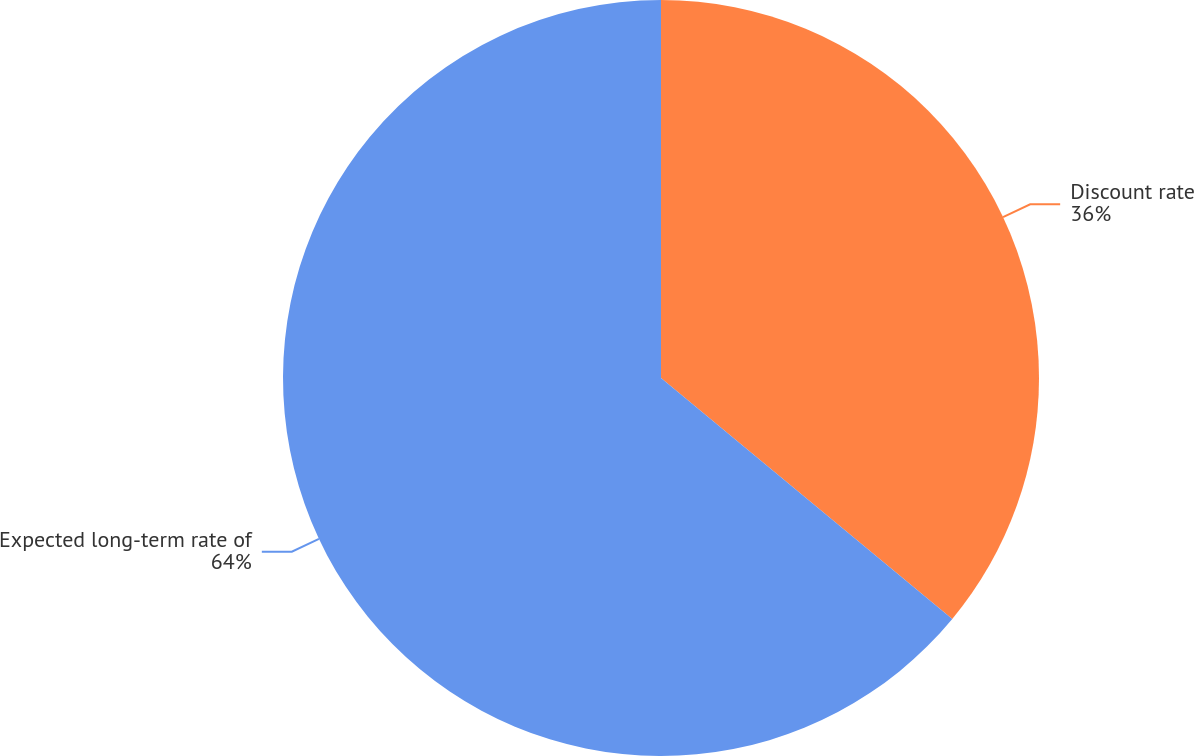Convert chart. <chart><loc_0><loc_0><loc_500><loc_500><pie_chart><fcel>Discount rate<fcel>Expected long-term rate of<nl><fcel>36.0%<fcel>64.0%<nl></chart> 